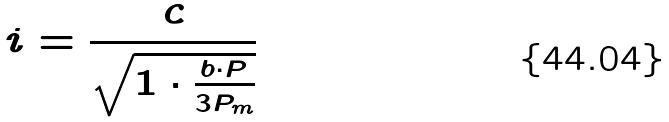<formula> <loc_0><loc_0><loc_500><loc_500>i = \frac { c } { \sqrt { 1 \cdot \frac { b \cdot P } { 3 P _ { m } } } }</formula> 